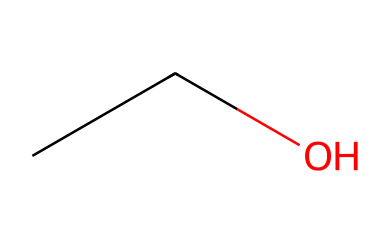What is the molecular formula of this compound? The SMILES representation "CCO" indicates there are two carbon atoms (C) and six hydrogen atoms (H) bonded to these oxygen atoms (O). Therefore, the molecular formula can be determined by counting the elements represented in the SMILES string. The resulting formula is C2H6O.
Answer: C2H6O How many carbon atoms are in ethanol? Looking at the SMILES representation "CCO", we can see there are two 'C' atoms present, which represent two carbon atoms in the structure of ethanol.
Answer: 2 What type of alcohol is represented by this structure? The structure given as "CCO" corresponds to ethanol, which is a type of simple alcohol commonly found in alcoholic beverages.
Answer: ethanol How many hydrogen atoms are attached to the carbon atoms in this molecule? In the chemical structure "CCO", the first carbon atom (C) can connect to three hydrogen atoms, and the second carbon is connected to two hydrogen atoms, resulting in a total of five hydrogen atoms connected to the two carbon atoms, plus one hydrogen on the hydroxyl group (-OH) making a total of six.
Answer: 6 What type of functional group is present in ethanol? The presence of 'O' in the SMILES "CCO" indicates that there is a hydroxyl group (-OH) attached to one of the carbon atoms, which identifies this compound as an alcohol due to the distinctive functional group.
Answer: hydroxyl Can ethanol undergo fermentation? Given that ethanol is derived from the fermentation of sugars, this indicates that it can undergo fermentation as it is a product of the metabolic process that converts sugar to alcohol and carbon dioxide.
Answer: yes Is ethanol a saturated or unsaturated hydrocarbon? The structure "CCO" does not contain any double or triple bonds between carbon atoms, which means it is saturated; saturated hydrocarbons have the maximum number of hydrogen atoms attached to each carbon atom.
Answer: saturated 